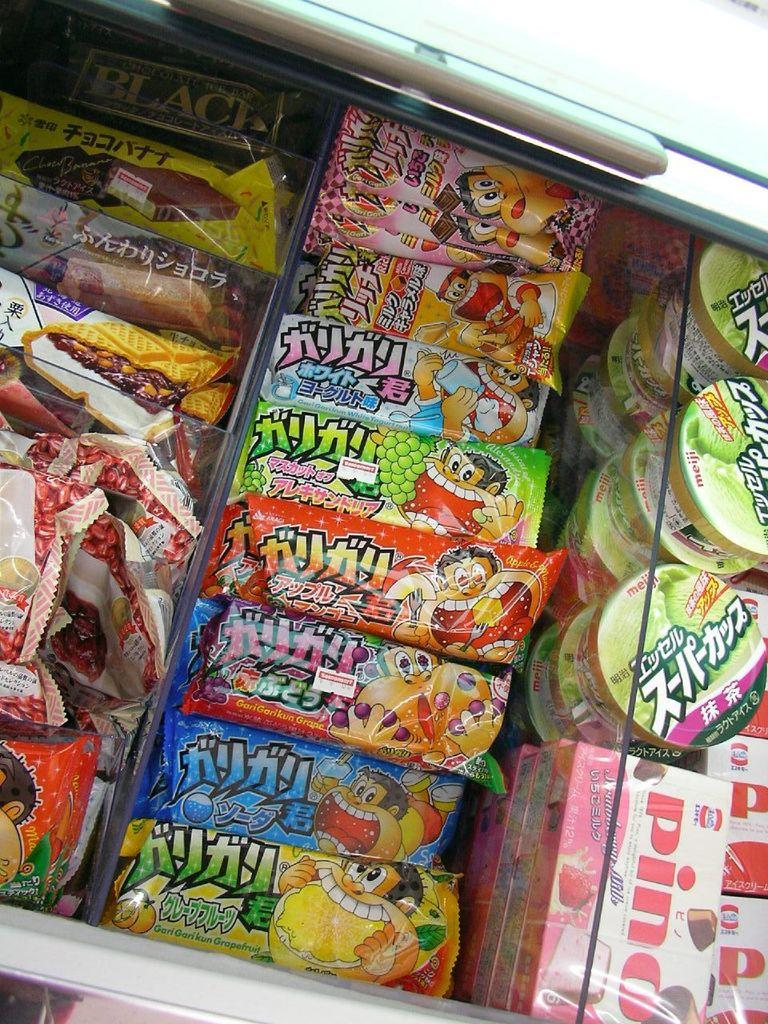<image>
Present a compact description of the photo's key features. A case of asian treats including some Pinos. 